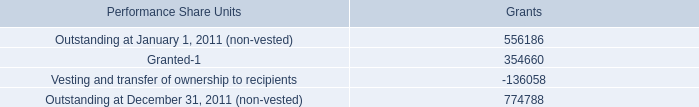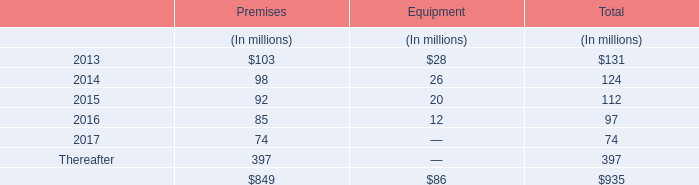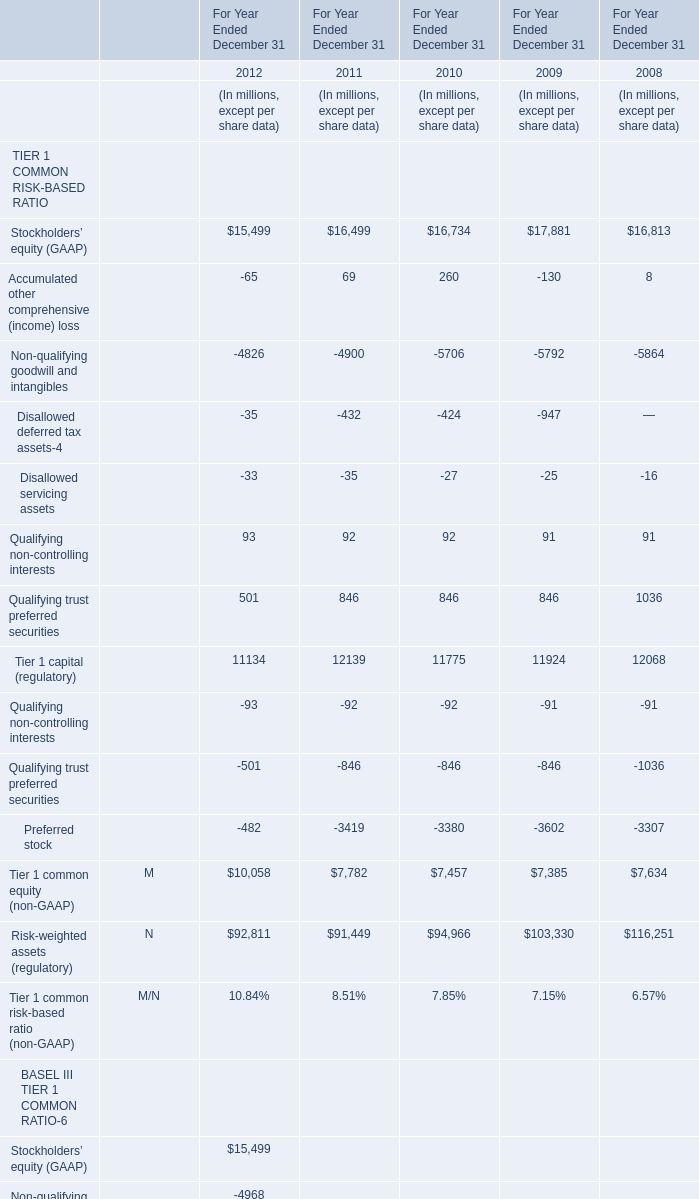what percentage of july 2011 performance shares does not relate to post-merger services? 
Computations: ((8.6 - 7.3) / 8.6)
Answer: 0.15116. 